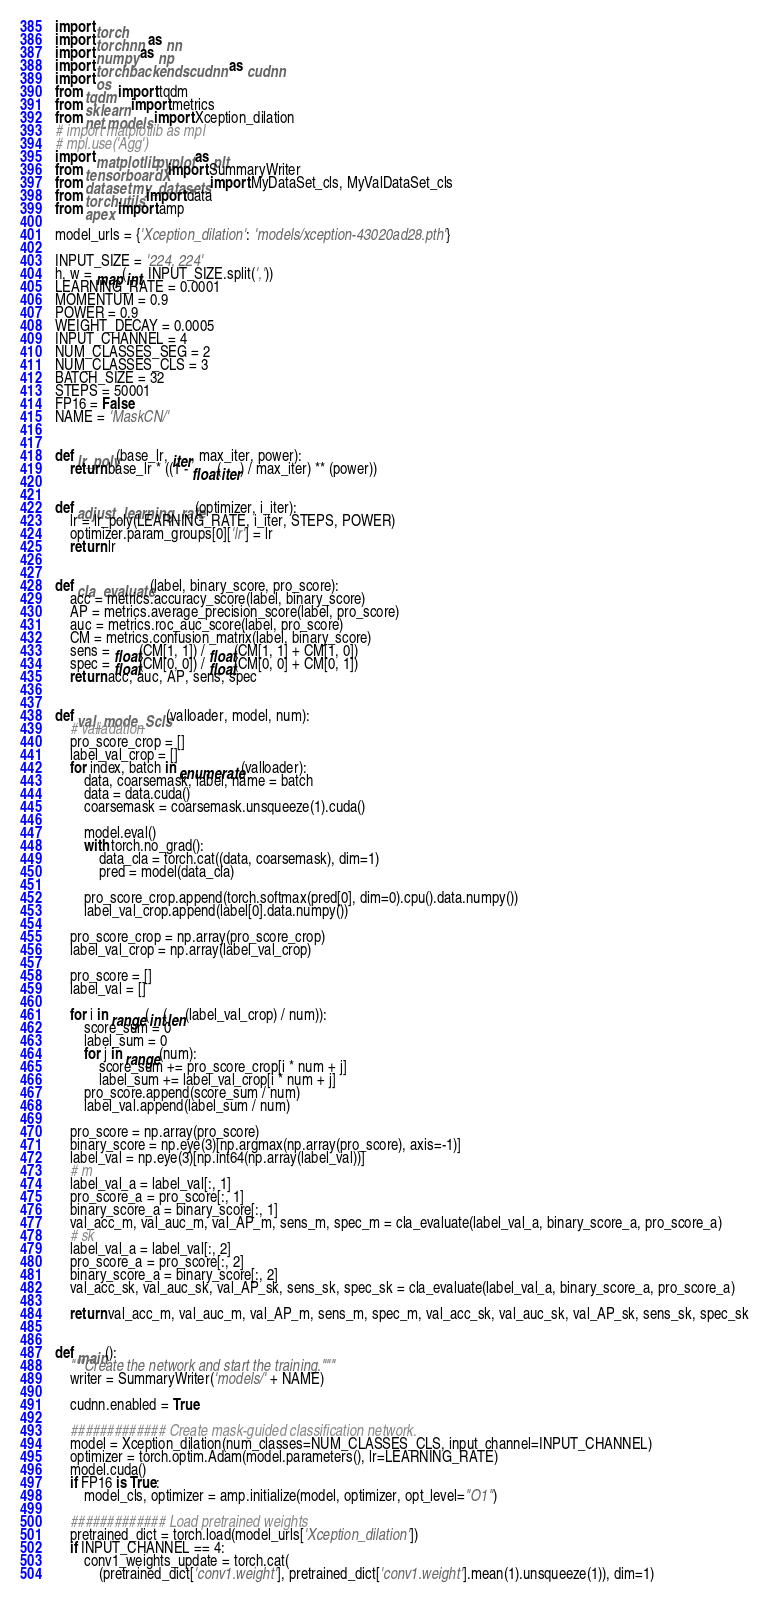<code> <loc_0><loc_0><loc_500><loc_500><_Python_>import torch
import torch.nn as nn
import numpy as np
import torch.backends.cudnn as cudnn
import os
from tqdm import tqdm
from sklearn import metrics
from net.models import Xception_dilation
# import matplotlib as mpl
# mpl.use('Agg')
import matplotlib.pyplot as plt
from tensorboardX import SummaryWriter
from dataset.my_datasets import MyDataSet_cls, MyValDataSet_cls
from torch.utils import data
from apex import amp

model_urls = {'Xception_dilation': 'models/xception-43020ad28.pth'}

INPUT_SIZE = '224, 224'
h, w = map(int, INPUT_SIZE.split(','))
LEARNING_RATE = 0.0001
MOMENTUM = 0.9
POWER = 0.9
WEIGHT_DECAY = 0.0005
INPUT_CHANNEL = 4
NUM_CLASSES_SEG = 2
NUM_CLASSES_CLS = 3
BATCH_SIZE = 32
STEPS = 50001
FP16 = False
NAME = 'MaskCN/'


def lr_poly(base_lr, iter, max_iter, power):
    return base_lr * ((1 - float(iter) / max_iter) ** (power))


def adjust_learning_rate(optimizer, i_iter):
    lr = lr_poly(LEARNING_RATE, i_iter, STEPS, POWER)
    optimizer.param_groups[0]['lr'] = lr
    return lr


def cla_evaluate(label, binary_score, pro_score):
    acc = metrics.accuracy_score(label, binary_score)
    AP = metrics.average_precision_score(label, pro_score)
    auc = metrics.roc_auc_score(label, pro_score)
    CM = metrics.confusion_matrix(label, binary_score)
    sens = float(CM[1, 1]) / float(CM[1, 1] + CM[1, 0])
    spec = float(CM[0, 0]) / float(CM[0, 0] + CM[0, 1])
    return acc, auc, AP, sens, spec


def val_mode_Scls(valloader, model, num):
    # valiadation
    pro_score_crop = []
    label_val_crop = []
    for index, batch in enumerate(valloader):
        data, coarsemask, label, name = batch
        data = data.cuda()
        coarsemask = coarsemask.unsqueeze(1).cuda()

        model.eval()
        with torch.no_grad():
            data_cla = torch.cat((data, coarsemask), dim=1)
            pred = model(data_cla)

        pro_score_crop.append(torch.softmax(pred[0], dim=0).cpu().data.numpy())
        label_val_crop.append(label[0].data.numpy())

    pro_score_crop = np.array(pro_score_crop)
    label_val_crop = np.array(label_val_crop)

    pro_score = []
    label_val = []

    for i in range(int(len(label_val_crop) / num)):
        score_sum = 0
        label_sum = 0
        for j in range(num):
            score_sum += pro_score_crop[i * num + j]
            label_sum += label_val_crop[i * num + j]
        pro_score.append(score_sum / num)
        label_val.append(label_sum / num)

    pro_score = np.array(pro_score)
    binary_score = np.eye(3)[np.argmax(np.array(pro_score), axis=-1)]
    label_val = np.eye(3)[np.int64(np.array(label_val))]
    # m
    label_val_a = label_val[:, 1]
    pro_score_a = pro_score[:, 1]
    binary_score_a = binary_score[:, 1]
    val_acc_m, val_auc_m, val_AP_m, sens_m, spec_m = cla_evaluate(label_val_a, binary_score_a, pro_score_a)
    # sk
    label_val_a = label_val[:, 2]
    pro_score_a = pro_score[:, 2]
    binary_score_a = binary_score[:, 2]
    val_acc_sk, val_auc_sk, val_AP_sk, sens_sk, spec_sk = cla_evaluate(label_val_a, binary_score_a, pro_score_a)

    return val_acc_m, val_auc_m, val_AP_m, sens_m, spec_m, val_acc_sk, val_auc_sk, val_AP_sk, sens_sk, spec_sk


def main():
    """Create the network and start the training."""
    writer = SummaryWriter('models/' + NAME)

    cudnn.enabled = True

    ############# Create mask-guided classification network.
    model = Xception_dilation(num_classes=NUM_CLASSES_CLS, input_channel=INPUT_CHANNEL)
    optimizer = torch.optim.Adam(model.parameters(), lr=LEARNING_RATE)
    model.cuda()
    if FP16 is True:
        model_cls, optimizer = amp.initialize(model, optimizer, opt_level="O1")

    ############# Load pretrained weights
    pretrained_dict = torch.load(model_urls['Xception_dilation'])
    if INPUT_CHANNEL == 4:
        conv1_weights_update = torch.cat(
            (pretrained_dict['conv1.weight'], pretrained_dict['conv1.weight'].mean(1).unsqueeze(1)), dim=1)</code> 